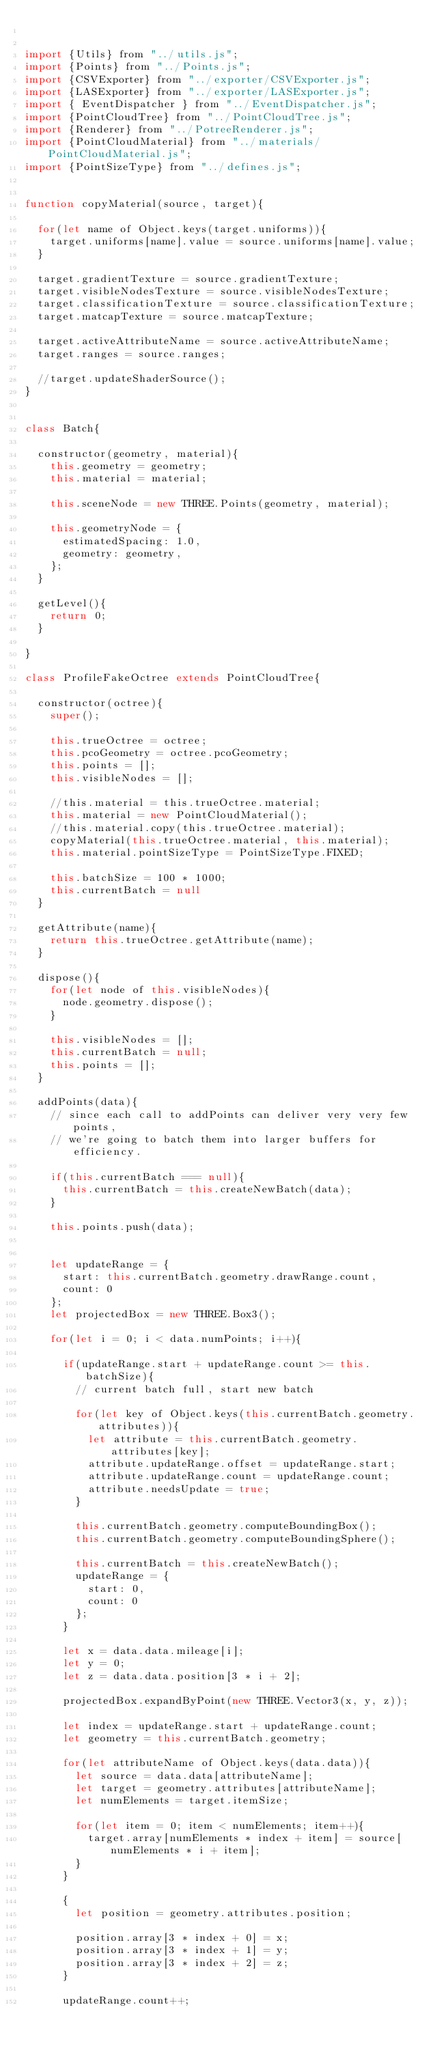<code> <loc_0><loc_0><loc_500><loc_500><_JavaScript_>

import {Utils} from "../utils.js";
import {Points} from "../Points.js";
import {CSVExporter} from "../exporter/CSVExporter.js";
import {LASExporter} from "../exporter/LASExporter.js";
import { EventDispatcher } from "../EventDispatcher.js";
import {PointCloudTree} from "../PointCloudTree.js";
import {Renderer} from "../PotreeRenderer.js";
import {PointCloudMaterial} from "../materials/PointCloudMaterial.js";
import {PointSizeType} from "../defines.js";


function copyMaterial(source, target){

	for(let name of Object.keys(target.uniforms)){
		target.uniforms[name].value = source.uniforms[name].value;
	}

	target.gradientTexture = source.gradientTexture;
	target.visibleNodesTexture = source.visibleNodesTexture;
	target.classificationTexture = source.classificationTexture;
	target.matcapTexture = source.matcapTexture;

	target.activeAttributeName = source.activeAttributeName;
	target.ranges = source.ranges;

	//target.updateShaderSource();
}


class Batch{

	constructor(geometry, material){
		this.geometry = geometry;
		this.material = material;

		this.sceneNode = new THREE.Points(geometry, material);

		this.geometryNode = {
			estimatedSpacing: 1.0,
			geometry: geometry,
		};
	}

	getLevel(){
		return 0;
	}

}

class ProfileFakeOctree extends PointCloudTree{

	constructor(octree){
		super();

		this.trueOctree = octree;
		this.pcoGeometry = octree.pcoGeometry;
		this.points = [];
		this.visibleNodes = [];
		
		//this.material = this.trueOctree.material;
		this.material = new PointCloudMaterial();
		//this.material.copy(this.trueOctree.material);
		copyMaterial(this.trueOctree.material, this.material);
		this.material.pointSizeType = PointSizeType.FIXED;

		this.batchSize = 100 * 1000;
		this.currentBatch = null
	}

	getAttribute(name){
		return this.trueOctree.getAttribute(name);
	}

	dispose(){
		for(let node of this.visibleNodes){
			node.geometry.dispose();
		}

		this.visibleNodes = [];
		this.currentBatch = null;
		this.points = [];
	}

	addPoints(data){
		// since each call to addPoints can deliver very very few points,
		// we're going to batch them into larger buffers for efficiency.

		if(this.currentBatch === null){
			this.currentBatch = this.createNewBatch(data);
		}

		this.points.push(data);


		let updateRange = {
			start: this.currentBatch.geometry.drawRange.count,
			count: 0
		};
		let projectedBox = new THREE.Box3();

		for(let i = 0; i < data.numPoints; i++){

			if(updateRange.start + updateRange.count >= this.batchSize){
				// current batch full, start new batch

				for(let key of Object.keys(this.currentBatch.geometry.attributes)){
					let attribute = this.currentBatch.geometry.attributes[key];
					attribute.updateRange.offset = updateRange.start;
					attribute.updateRange.count = updateRange.count;
					attribute.needsUpdate = true;
				}

				this.currentBatch.geometry.computeBoundingBox();
				this.currentBatch.geometry.computeBoundingSphere();

				this.currentBatch = this.createNewBatch();
				updateRange = {
					start: 0,
					count: 0
				};
			}

			let x = data.data.mileage[i];
			let y = 0;
			let z = data.data.position[3 * i + 2];

			projectedBox.expandByPoint(new THREE.Vector3(x, y, z));

			let index = updateRange.start + updateRange.count;
			let geometry = this.currentBatch.geometry;

			for(let attributeName of Object.keys(data.data)){
				let source = data.data[attributeName];
				let target = geometry.attributes[attributeName];
				let numElements = target.itemSize;
				
				for(let item = 0; item < numElements; item++){
					target.array[numElements * index + item] = source[numElements * i + item];
				}
			}

			{
				let position = geometry.attributes.position;

				position.array[3 * index + 0] = x;
				position.array[3 * index + 1] = y;
				position.array[3 * index + 2] = z;
			}

			updateRange.count++;</code> 